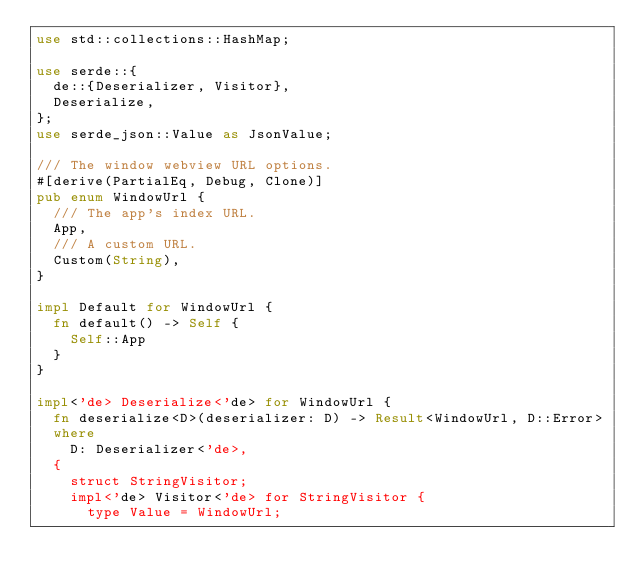Convert code to text. <code><loc_0><loc_0><loc_500><loc_500><_Rust_>use std::collections::HashMap;

use serde::{
  de::{Deserializer, Visitor},
  Deserialize,
};
use serde_json::Value as JsonValue;

/// The window webview URL options.
#[derive(PartialEq, Debug, Clone)]
pub enum WindowUrl {
  /// The app's index URL.
  App,
  /// A custom URL.
  Custom(String),
}

impl Default for WindowUrl {
  fn default() -> Self {
    Self::App
  }
}

impl<'de> Deserialize<'de> for WindowUrl {
  fn deserialize<D>(deserializer: D) -> Result<WindowUrl, D::Error>
  where
    D: Deserializer<'de>,
  {
    struct StringVisitor;
    impl<'de> Visitor<'de> for StringVisitor {
      type Value = WindowUrl;</code> 